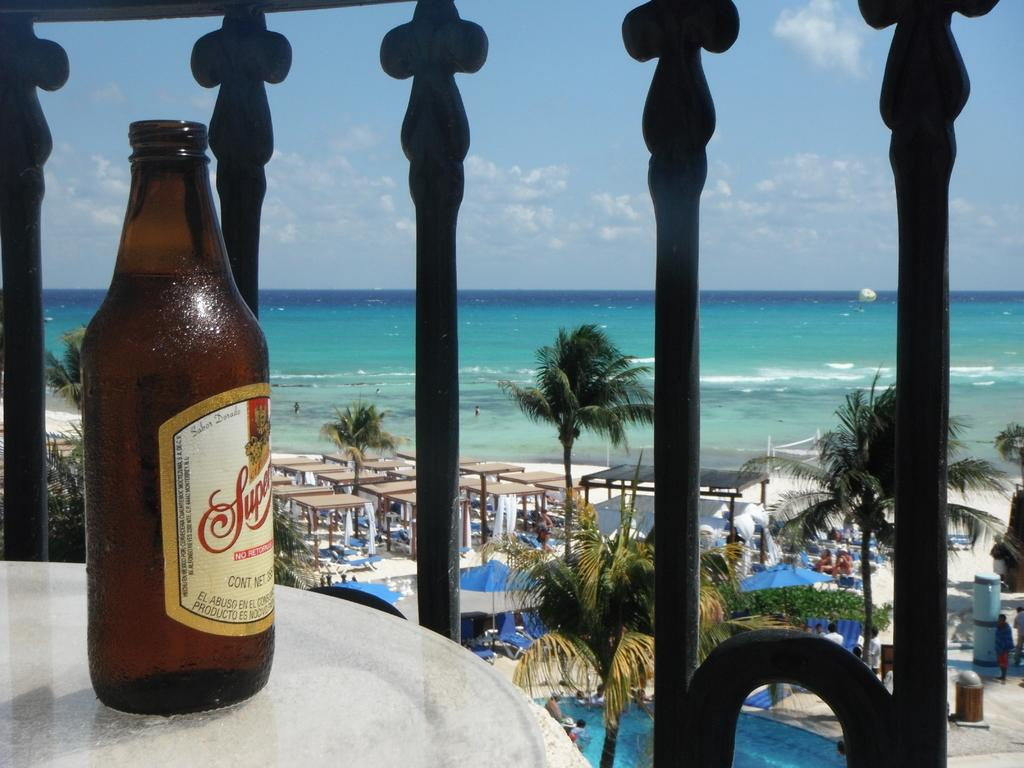What object is on the table in the image? There is a bottle on the table in the image. What type of natural elements can be seen in the image? There are trees and a beach in the image. How are the trees depicted in the image? The trees have some tints in the image. Where is the swimming pool located in the image? The swimming pool is in the bottom corner of the image. What is the color of the sky above the beach? The sky above the beach is blue in the image. Are there any clouds visible in the sky above the beach? Yes, there are clouds in the sky above the beach in the image. What type of disease is affecting the trees in the image? There is no indication of any disease affecting the trees in the image. Can you tell me how many donkeys are present on the beach in the image? There are no donkeys present on the beach in the image. 